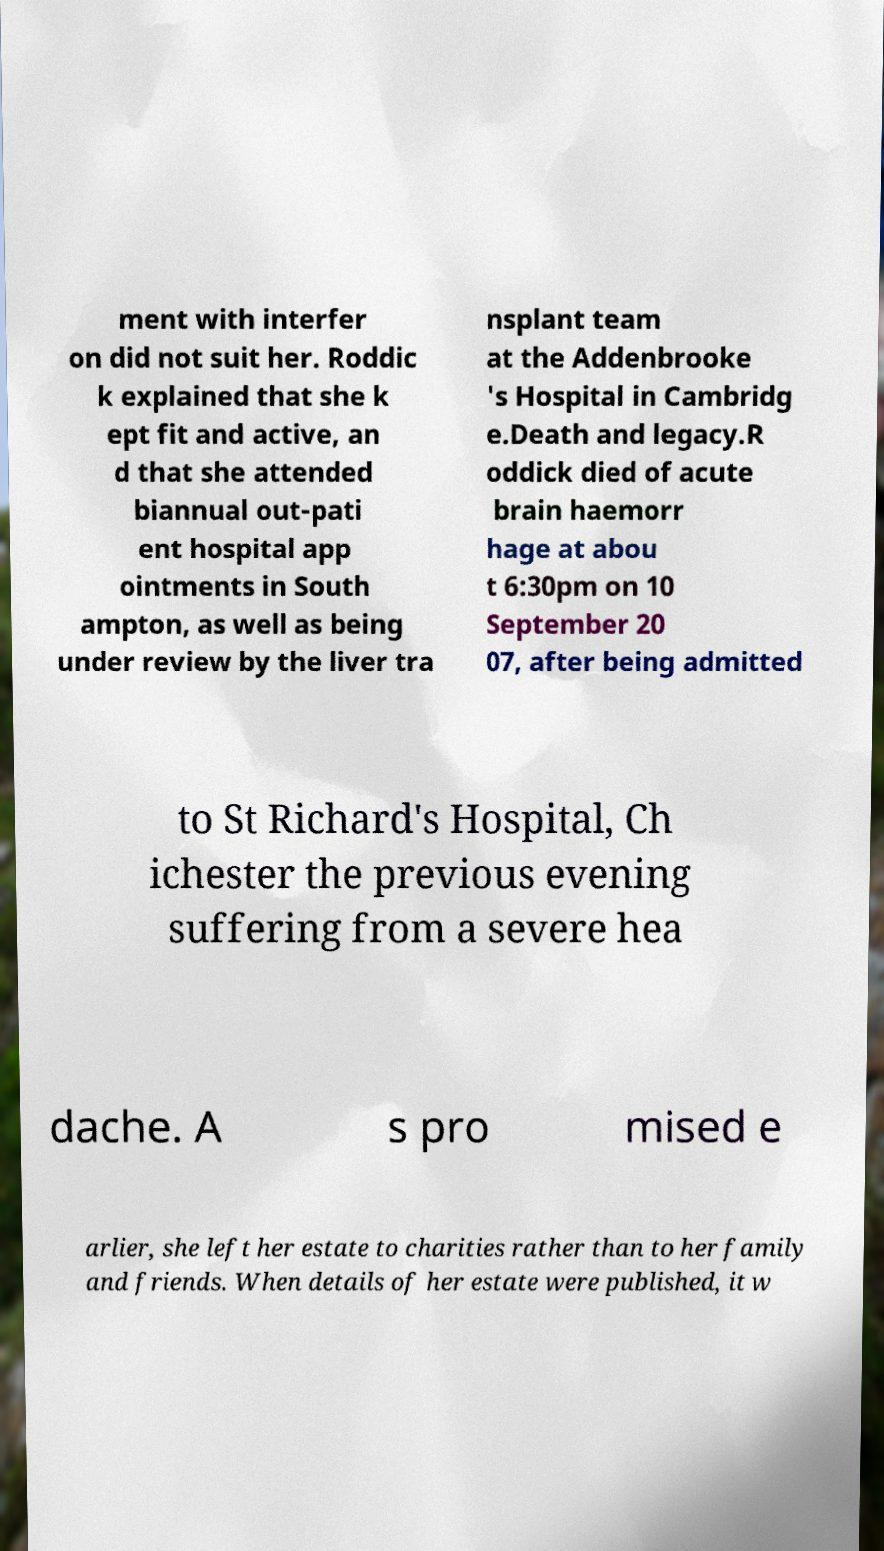Could you extract and type out the text from this image? ment with interfer on did not suit her. Roddic k explained that she k ept fit and active, an d that she attended biannual out-pati ent hospital app ointments in South ampton, as well as being under review by the liver tra nsplant team at the Addenbrooke 's Hospital in Cambridg e.Death and legacy.R oddick died of acute brain haemorr hage at abou t 6:30pm on 10 September 20 07, after being admitted to St Richard's Hospital, Ch ichester the previous evening suffering from a severe hea dache. A s pro mised e arlier, she left her estate to charities rather than to her family and friends. When details of her estate were published, it w 